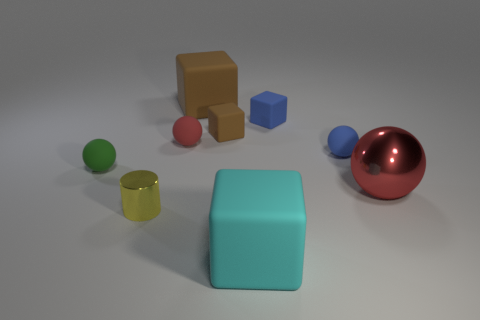Subtract all blue rubber balls. How many balls are left? 3 Add 1 yellow objects. How many objects exist? 10 Subtract all purple cylinders. How many brown blocks are left? 2 Subtract all red spheres. How many spheres are left? 2 Subtract 1 blocks. How many blocks are left? 3 Subtract all spheres. How many objects are left? 5 Subtract all green balls. Subtract all red cubes. How many balls are left? 3 Add 7 tiny red matte objects. How many tiny red matte objects exist? 8 Subtract 1 blue spheres. How many objects are left? 8 Subtract all large objects. Subtract all big brown things. How many objects are left? 5 